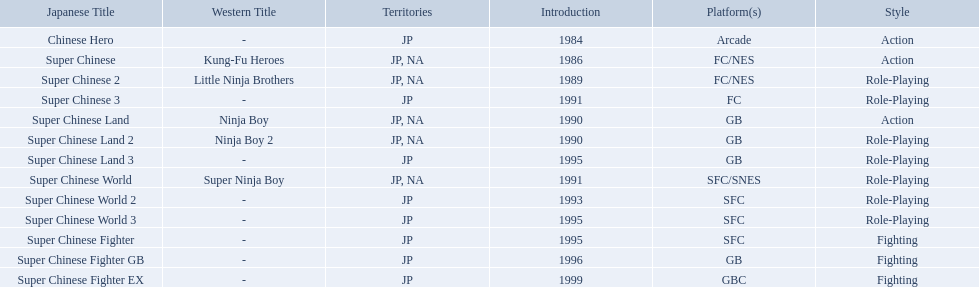Super ninja world was released in what countries? JP, NA. What was the original name for this title? Super Chinese World. 